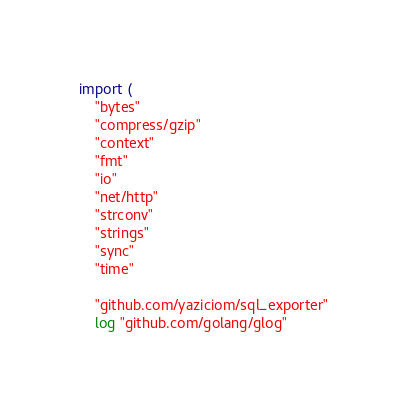<code> <loc_0><loc_0><loc_500><loc_500><_Go_>
import (
	"bytes"
	"compress/gzip"
	"context"
	"fmt"
	"io"
	"net/http"
	"strconv"
	"strings"
	"sync"
	"time"

	"github.com/yaziciom/sql_exporter"
	log "github.com/golang/glog"</code> 